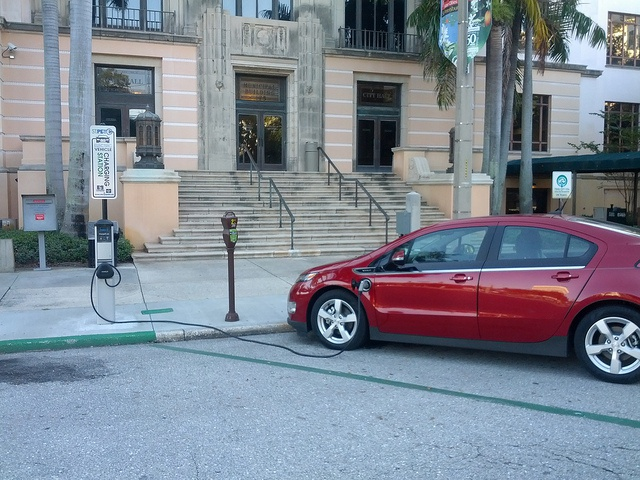Describe the objects in this image and their specific colors. I can see car in darkgray, maroon, black, purple, and blue tones and parking meter in darkgray, gray, black, and green tones in this image. 